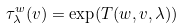Convert formula to latex. <formula><loc_0><loc_0><loc_500><loc_500>\tau ^ { w } _ { \lambda } ( v ) = \exp ( T ( w , v , \lambda ) )</formula> 